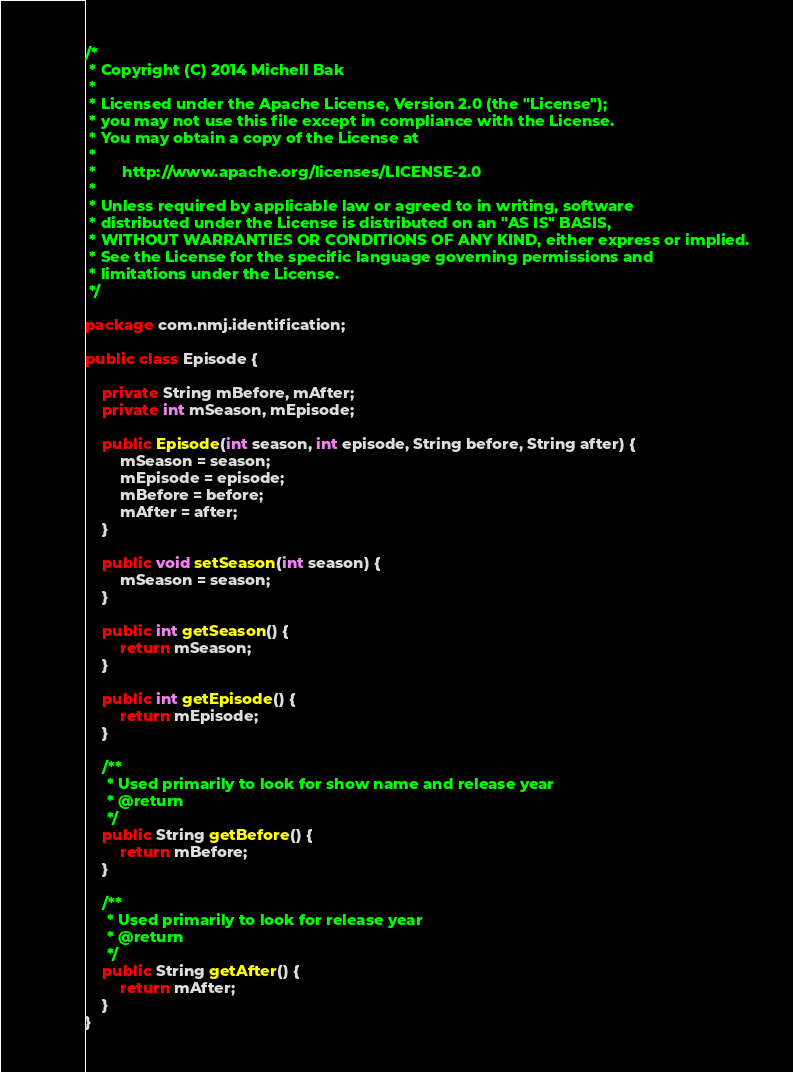<code> <loc_0><loc_0><loc_500><loc_500><_Java_>/*
 * Copyright (C) 2014 Michell Bak
 *
 * Licensed under the Apache License, Version 2.0 (the "License");
 * you may not use this file except in compliance with the License.
 * You may obtain a copy of the License at
 *
 *      http://www.apache.org/licenses/LICENSE-2.0
 *
 * Unless required by applicable law or agreed to in writing, software
 * distributed under the License is distributed on an "AS IS" BASIS,
 * WITHOUT WARRANTIES OR CONDITIONS OF ANY KIND, either express or implied.
 * See the License for the specific language governing permissions and
 * limitations under the License.
 */

package com.nmj.identification;

public class Episode {

	private String mBefore, mAfter;
	private int mSeason, mEpisode;

	public Episode(int season, int episode, String before, String after) {
		mSeason = season;
		mEpisode = episode;
		mBefore = before;
		mAfter = after;
	}

	public void setSeason(int season) {
		mSeason = season;
	}

	public int getSeason() {
		return mSeason;
	}

	public int getEpisode() {
		return mEpisode;
	}

	/**
	 * Used primarily to look for show name and release year
	 * @return
	 */
	public String getBefore() {
		return mBefore;
	}

	/**
	 * Used primarily to look for release year
	 * @return
	 */
	public String getAfter() {
		return mAfter;
	}
}</code> 